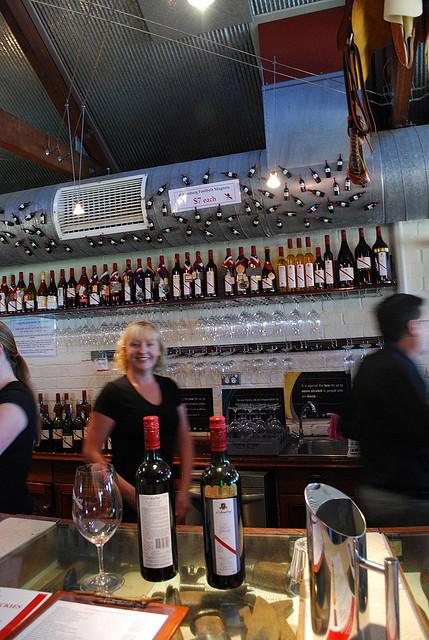Is the woman studying a menu in front of a restaurant?
Short answer required. No. How many bottles are pictured?
Keep it brief. 2. Does the woman look happy?
Be succinct. Yes. Can I order a drink at this establishment?
Answer briefly. Yes. 